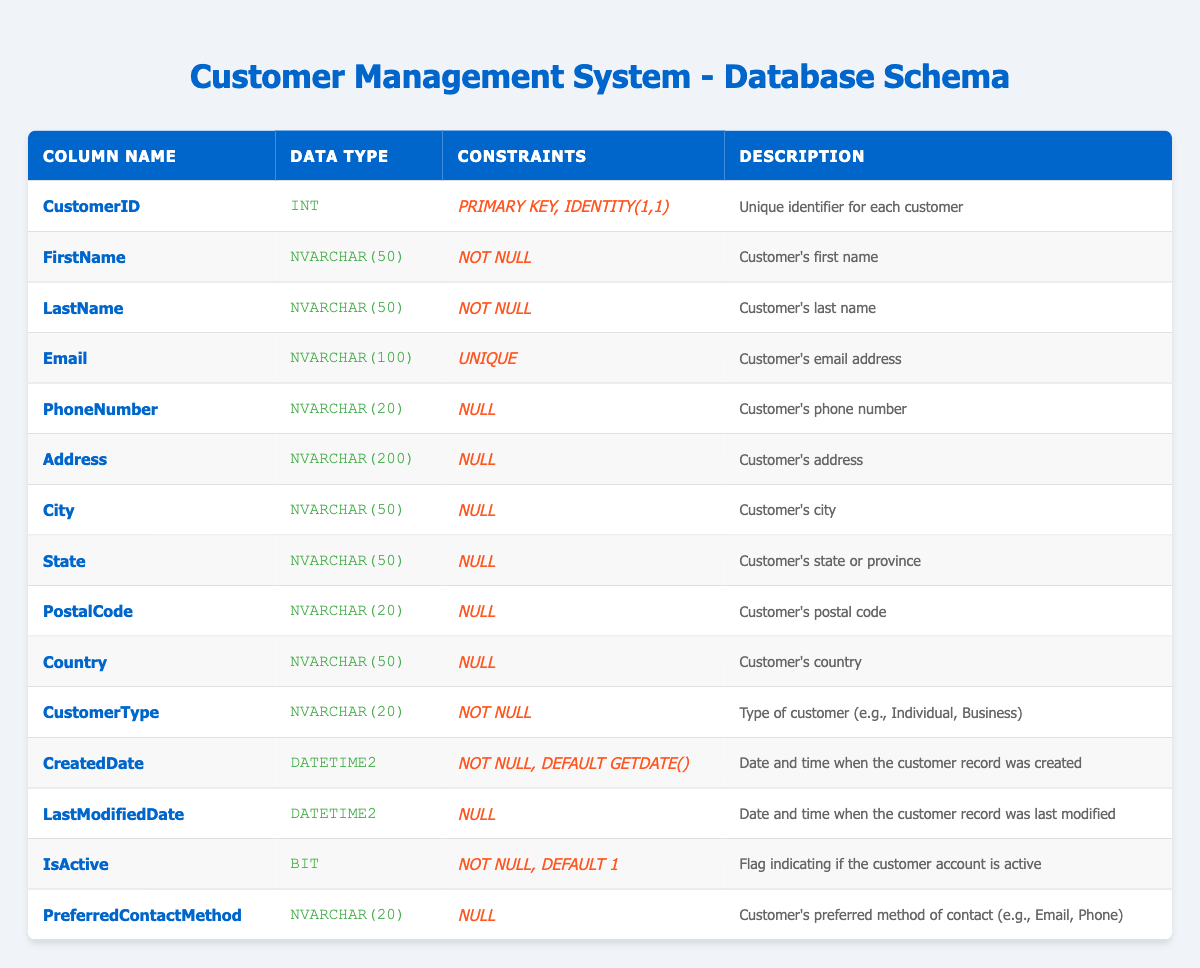What is the data type of the CustomerID column? The CustomerID column specifies its data type as INT, which indicates it holds integer values.
Answer: INT Is the Email column required for each customer? The Email column has a UNIQUE constraint, which means every customer must have a unique email address, indicating it is required.
Answer: Yes How many columns are there in total in this table? The table lists 14 columns, which can be counted in the table header and confirmed by counting the rows in the body for each column specification.
Answer: 14 What is the default value for the CreatedDate column? The CreatedDate column specifies a default value of GETDATE(), which indicates it will automatically be set to the current date and time when a new record is created.
Answer: GETDATE() Which columns allow NULL values? The columns that allow NULL values are PhoneNumber, Address, City, State, PostalCode, Country, LastModifiedDate, and PreferredContactMethod. Counting the relevant rows confirms these columns have NULL specified in their constraints.
Answer: PhoneNumber, Address, City, State, PostalCode, Country, LastModifiedDate, PreferredContactMethod What is the average length of the data types for all the NVARCHAR columns? There are 8 NVARCHAR columns with the following lengths: 50, 50, 100, 20, 200, 50, 50, 20. The sum is 50 + 50 + 100 + 20 + 200 + 50 + 50 + 20 = 540. Dividing by 8 columns gives the average length of 540 / 8 = 67.5.
Answer: 67.5 Is the CustomerType column optional? The CustomerType column has a NOT NULL constraint, indicating that this column must have a value and cannot be left empty.
Answer: No What is the significance of the IsActive column? The IsActive column indicates whether the customer's account is currently active, with a default setting of 1 meaning active. This provides a clear flag for account status.
Answer: Indicates account status How many customers can have the same email address? Due to the UNIQUE constraint on the Email column, no two customers can share the same email address, ensuring that each email is unique.
Answer: 0 